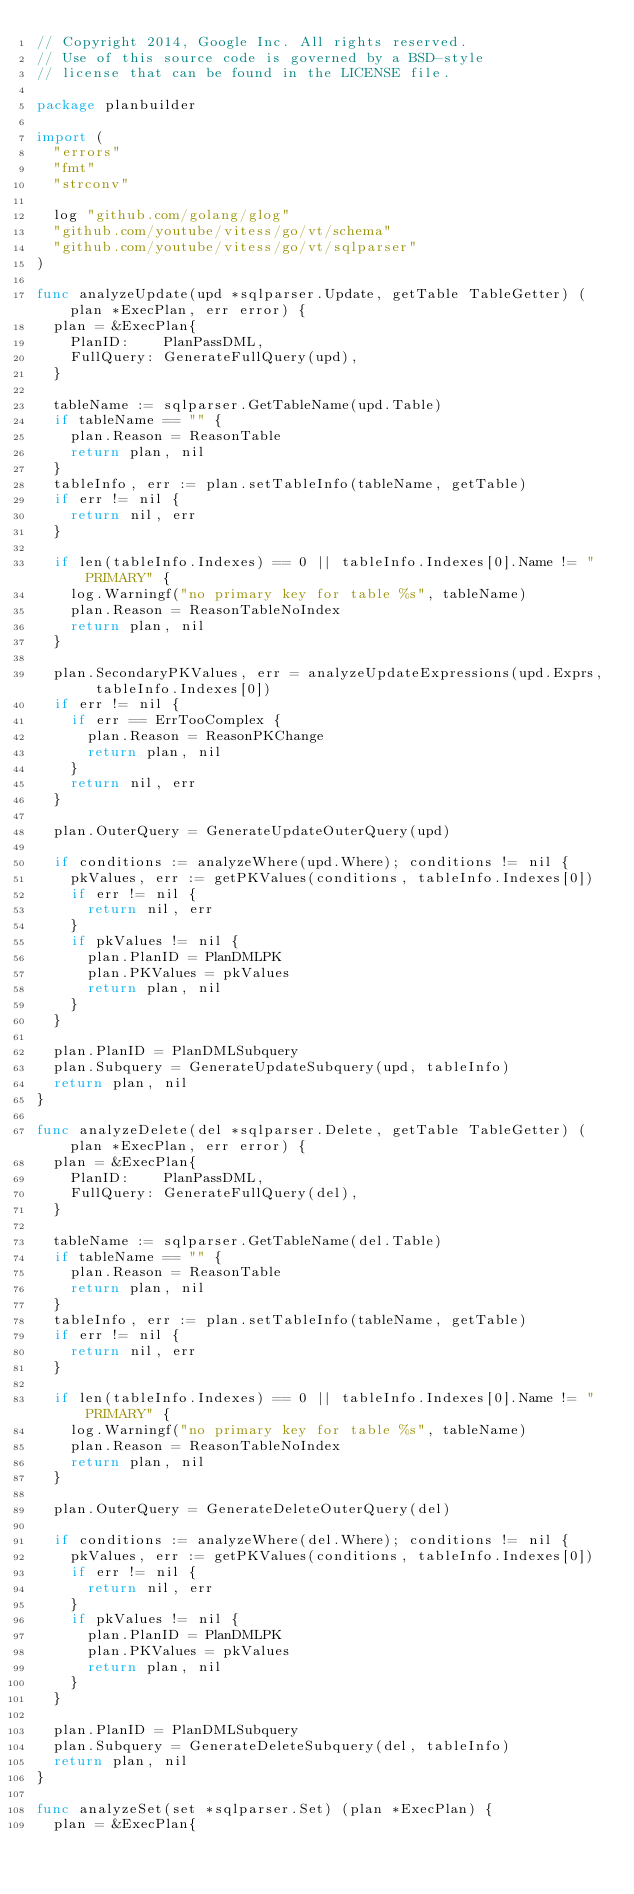Convert code to text. <code><loc_0><loc_0><loc_500><loc_500><_Go_>// Copyright 2014, Google Inc. All rights reserved.
// Use of this source code is governed by a BSD-style
// license that can be found in the LICENSE file.

package planbuilder

import (
	"errors"
	"fmt"
	"strconv"

	log "github.com/golang/glog"
	"github.com/youtube/vitess/go/vt/schema"
	"github.com/youtube/vitess/go/vt/sqlparser"
)

func analyzeUpdate(upd *sqlparser.Update, getTable TableGetter) (plan *ExecPlan, err error) {
	plan = &ExecPlan{
		PlanID:    PlanPassDML,
		FullQuery: GenerateFullQuery(upd),
	}

	tableName := sqlparser.GetTableName(upd.Table)
	if tableName == "" {
		plan.Reason = ReasonTable
		return plan, nil
	}
	tableInfo, err := plan.setTableInfo(tableName, getTable)
	if err != nil {
		return nil, err
	}

	if len(tableInfo.Indexes) == 0 || tableInfo.Indexes[0].Name != "PRIMARY" {
		log.Warningf("no primary key for table %s", tableName)
		plan.Reason = ReasonTableNoIndex
		return plan, nil
	}

	plan.SecondaryPKValues, err = analyzeUpdateExpressions(upd.Exprs, tableInfo.Indexes[0])
	if err != nil {
		if err == ErrTooComplex {
			plan.Reason = ReasonPKChange
			return plan, nil
		}
		return nil, err
	}

	plan.OuterQuery = GenerateUpdateOuterQuery(upd)

	if conditions := analyzeWhere(upd.Where); conditions != nil {
		pkValues, err := getPKValues(conditions, tableInfo.Indexes[0])
		if err != nil {
			return nil, err
		}
		if pkValues != nil {
			plan.PlanID = PlanDMLPK
			plan.PKValues = pkValues
			return plan, nil
		}
	}

	plan.PlanID = PlanDMLSubquery
	plan.Subquery = GenerateUpdateSubquery(upd, tableInfo)
	return plan, nil
}

func analyzeDelete(del *sqlparser.Delete, getTable TableGetter) (plan *ExecPlan, err error) {
	plan = &ExecPlan{
		PlanID:    PlanPassDML,
		FullQuery: GenerateFullQuery(del),
	}

	tableName := sqlparser.GetTableName(del.Table)
	if tableName == "" {
		plan.Reason = ReasonTable
		return plan, nil
	}
	tableInfo, err := plan.setTableInfo(tableName, getTable)
	if err != nil {
		return nil, err
	}

	if len(tableInfo.Indexes) == 0 || tableInfo.Indexes[0].Name != "PRIMARY" {
		log.Warningf("no primary key for table %s", tableName)
		plan.Reason = ReasonTableNoIndex
		return plan, nil
	}

	plan.OuterQuery = GenerateDeleteOuterQuery(del)

	if conditions := analyzeWhere(del.Where); conditions != nil {
		pkValues, err := getPKValues(conditions, tableInfo.Indexes[0])
		if err != nil {
			return nil, err
		}
		if pkValues != nil {
			plan.PlanID = PlanDMLPK
			plan.PKValues = pkValues
			return plan, nil
		}
	}

	plan.PlanID = PlanDMLSubquery
	plan.Subquery = GenerateDeleteSubquery(del, tableInfo)
	return plan, nil
}

func analyzeSet(set *sqlparser.Set) (plan *ExecPlan) {
	plan = &ExecPlan{</code> 